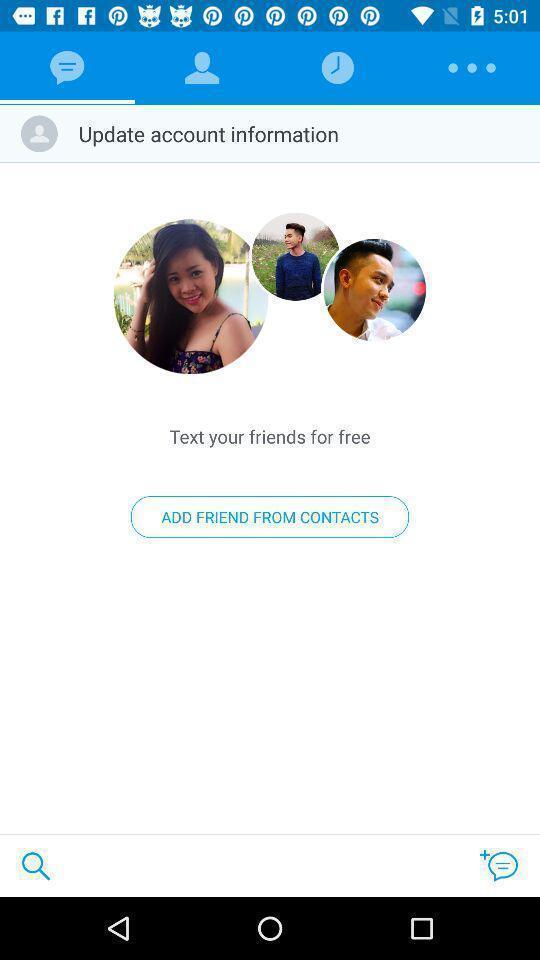Provide a textual representation of this image. Window displaying a messaging app. 